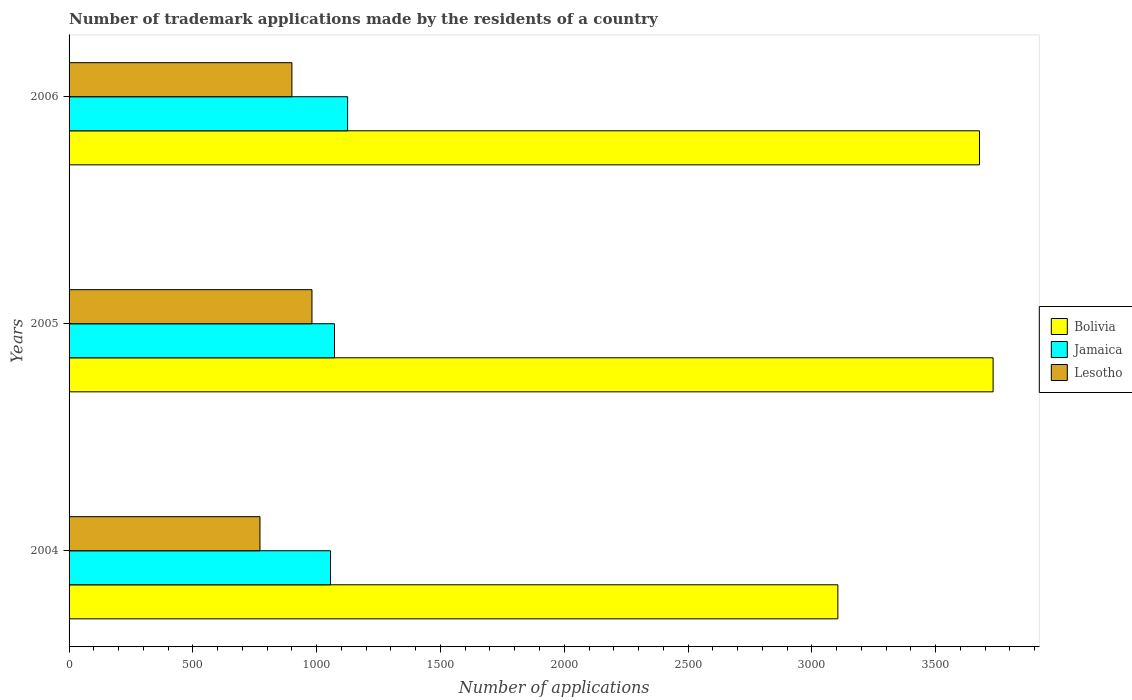How many groups of bars are there?
Ensure brevity in your answer.  3. Are the number of bars per tick equal to the number of legend labels?
Provide a short and direct response. Yes. How many bars are there on the 2nd tick from the bottom?
Your answer should be very brief. 3. What is the label of the 2nd group of bars from the top?
Provide a succinct answer. 2005. What is the number of trademark applications made by the residents in Bolivia in 2004?
Your answer should be compact. 3105. Across all years, what is the maximum number of trademark applications made by the residents in Lesotho?
Provide a short and direct response. 981. Across all years, what is the minimum number of trademark applications made by the residents in Bolivia?
Your answer should be compact. 3105. In which year was the number of trademark applications made by the residents in Jamaica maximum?
Offer a very short reply. 2006. What is the total number of trademark applications made by the residents in Bolivia in the graph?
Provide a short and direct response. 1.05e+04. What is the difference between the number of trademark applications made by the residents in Jamaica in 2005 and that in 2006?
Offer a very short reply. -53. What is the difference between the number of trademark applications made by the residents in Bolivia in 2004 and the number of trademark applications made by the residents in Jamaica in 2005?
Your answer should be compact. 2033. What is the average number of trademark applications made by the residents in Lesotho per year?
Your answer should be compact. 884. In the year 2006, what is the difference between the number of trademark applications made by the residents in Lesotho and number of trademark applications made by the residents in Bolivia?
Your answer should be compact. -2777. What is the ratio of the number of trademark applications made by the residents in Jamaica in 2004 to that in 2005?
Offer a terse response. 0.99. Is the number of trademark applications made by the residents in Jamaica in 2004 less than that in 2006?
Your response must be concise. Yes. What does the 3rd bar from the top in 2006 represents?
Provide a short and direct response. Bolivia. What does the 3rd bar from the bottom in 2006 represents?
Give a very brief answer. Lesotho. How many bars are there?
Provide a short and direct response. 9. How many years are there in the graph?
Give a very brief answer. 3. What is the difference between two consecutive major ticks on the X-axis?
Your answer should be compact. 500. Does the graph contain any zero values?
Keep it short and to the point. No. How are the legend labels stacked?
Offer a very short reply. Vertical. What is the title of the graph?
Keep it short and to the point. Number of trademark applications made by the residents of a country. What is the label or title of the X-axis?
Offer a terse response. Number of applications. What is the label or title of the Y-axis?
Give a very brief answer. Years. What is the Number of applications in Bolivia in 2004?
Make the answer very short. 3105. What is the Number of applications of Jamaica in 2004?
Provide a succinct answer. 1056. What is the Number of applications in Lesotho in 2004?
Provide a succinct answer. 771. What is the Number of applications in Bolivia in 2005?
Offer a terse response. 3732. What is the Number of applications of Jamaica in 2005?
Keep it short and to the point. 1072. What is the Number of applications in Lesotho in 2005?
Keep it short and to the point. 981. What is the Number of applications in Bolivia in 2006?
Your answer should be compact. 3677. What is the Number of applications of Jamaica in 2006?
Keep it short and to the point. 1125. What is the Number of applications in Lesotho in 2006?
Your response must be concise. 900. Across all years, what is the maximum Number of applications in Bolivia?
Give a very brief answer. 3732. Across all years, what is the maximum Number of applications in Jamaica?
Provide a succinct answer. 1125. Across all years, what is the maximum Number of applications in Lesotho?
Ensure brevity in your answer.  981. Across all years, what is the minimum Number of applications of Bolivia?
Make the answer very short. 3105. Across all years, what is the minimum Number of applications of Jamaica?
Your response must be concise. 1056. Across all years, what is the minimum Number of applications of Lesotho?
Your response must be concise. 771. What is the total Number of applications of Bolivia in the graph?
Your response must be concise. 1.05e+04. What is the total Number of applications of Jamaica in the graph?
Your answer should be compact. 3253. What is the total Number of applications in Lesotho in the graph?
Ensure brevity in your answer.  2652. What is the difference between the Number of applications in Bolivia in 2004 and that in 2005?
Offer a terse response. -627. What is the difference between the Number of applications of Lesotho in 2004 and that in 2005?
Make the answer very short. -210. What is the difference between the Number of applications of Bolivia in 2004 and that in 2006?
Provide a short and direct response. -572. What is the difference between the Number of applications in Jamaica in 2004 and that in 2006?
Offer a terse response. -69. What is the difference between the Number of applications of Lesotho in 2004 and that in 2006?
Keep it short and to the point. -129. What is the difference between the Number of applications of Bolivia in 2005 and that in 2006?
Give a very brief answer. 55. What is the difference between the Number of applications in Jamaica in 2005 and that in 2006?
Provide a short and direct response. -53. What is the difference between the Number of applications in Lesotho in 2005 and that in 2006?
Ensure brevity in your answer.  81. What is the difference between the Number of applications in Bolivia in 2004 and the Number of applications in Jamaica in 2005?
Offer a terse response. 2033. What is the difference between the Number of applications of Bolivia in 2004 and the Number of applications of Lesotho in 2005?
Ensure brevity in your answer.  2124. What is the difference between the Number of applications in Jamaica in 2004 and the Number of applications in Lesotho in 2005?
Ensure brevity in your answer.  75. What is the difference between the Number of applications in Bolivia in 2004 and the Number of applications in Jamaica in 2006?
Offer a terse response. 1980. What is the difference between the Number of applications in Bolivia in 2004 and the Number of applications in Lesotho in 2006?
Give a very brief answer. 2205. What is the difference between the Number of applications of Jamaica in 2004 and the Number of applications of Lesotho in 2006?
Provide a succinct answer. 156. What is the difference between the Number of applications of Bolivia in 2005 and the Number of applications of Jamaica in 2006?
Offer a terse response. 2607. What is the difference between the Number of applications in Bolivia in 2005 and the Number of applications in Lesotho in 2006?
Keep it short and to the point. 2832. What is the difference between the Number of applications in Jamaica in 2005 and the Number of applications in Lesotho in 2006?
Give a very brief answer. 172. What is the average Number of applications in Bolivia per year?
Keep it short and to the point. 3504.67. What is the average Number of applications in Jamaica per year?
Offer a very short reply. 1084.33. What is the average Number of applications of Lesotho per year?
Make the answer very short. 884. In the year 2004, what is the difference between the Number of applications in Bolivia and Number of applications in Jamaica?
Provide a succinct answer. 2049. In the year 2004, what is the difference between the Number of applications of Bolivia and Number of applications of Lesotho?
Provide a succinct answer. 2334. In the year 2004, what is the difference between the Number of applications in Jamaica and Number of applications in Lesotho?
Your response must be concise. 285. In the year 2005, what is the difference between the Number of applications in Bolivia and Number of applications in Jamaica?
Offer a terse response. 2660. In the year 2005, what is the difference between the Number of applications of Bolivia and Number of applications of Lesotho?
Provide a succinct answer. 2751. In the year 2005, what is the difference between the Number of applications of Jamaica and Number of applications of Lesotho?
Offer a very short reply. 91. In the year 2006, what is the difference between the Number of applications in Bolivia and Number of applications in Jamaica?
Your answer should be compact. 2552. In the year 2006, what is the difference between the Number of applications in Bolivia and Number of applications in Lesotho?
Keep it short and to the point. 2777. In the year 2006, what is the difference between the Number of applications of Jamaica and Number of applications of Lesotho?
Ensure brevity in your answer.  225. What is the ratio of the Number of applications of Bolivia in 2004 to that in 2005?
Ensure brevity in your answer.  0.83. What is the ratio of the Number of applications of Jamaica in 2004 to that in 2005?
Your answer should be very brief. 0.99. What is the ratio of the Number of applications in Lesotho in 2004 to that in 2005?
Offer a very short reply. 0.79. What is the ratio of the Number of applications of Bolivia in 2004 to that in 2006?
Keep it short and to the point. 0.84. What is the ratio of the Number of applications of Jamaica in 2004 to that in 2006?
Your answer should be compact. 0.94. What is the ratio of the Number of applications in Lesotho in 2004 to that in 2006?
Give a very brief answer. 0.86. What is the ratio of the Number of applications of Jamaica in 2005 to that in 2006?
Offer a very short reply. 0.95. What is the ratio of the Number of applications of Lesotho in 2005 to that in 2006?
Your answer should be compact. 1.09. What is the difference between the highest and the second highest Number of applications in Bolivia?
Provide a short and direct response. 55. What is the difference between the highest and the second highest Number of applications of Jamaica?
Ensure brevity in your answer.  53. What is the difference between the highest and the lowest Number of applications of Bolivia?
Provide a succinct answer. 627. What is the difference between the highest and the lowest Number of applications in Jamaica?
Your response must be concise. 69. What is the difference between the highest and the lowest Number of applications in Lesotho?
Your answer should be very brief. 210. 